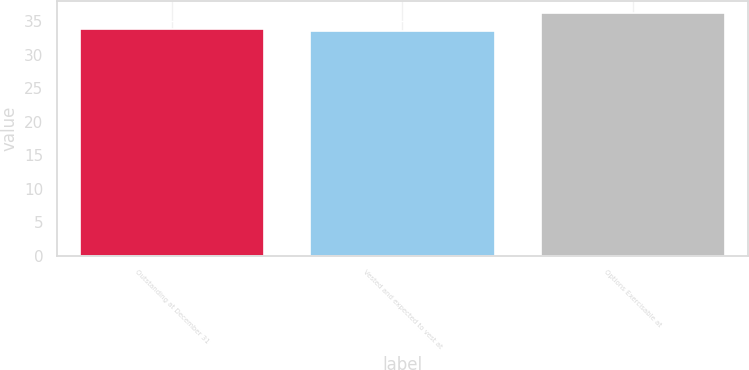<chart> <loc_0><loc_0><loc_500><loc_500><bar_chart><fcel>Outstanding at December 31<fcel>Vested and expected to vest at<fcel>Options Exercisable at<nl><fcel>33.81<fcel>33.54<fcel>36.24<nl></chart> 